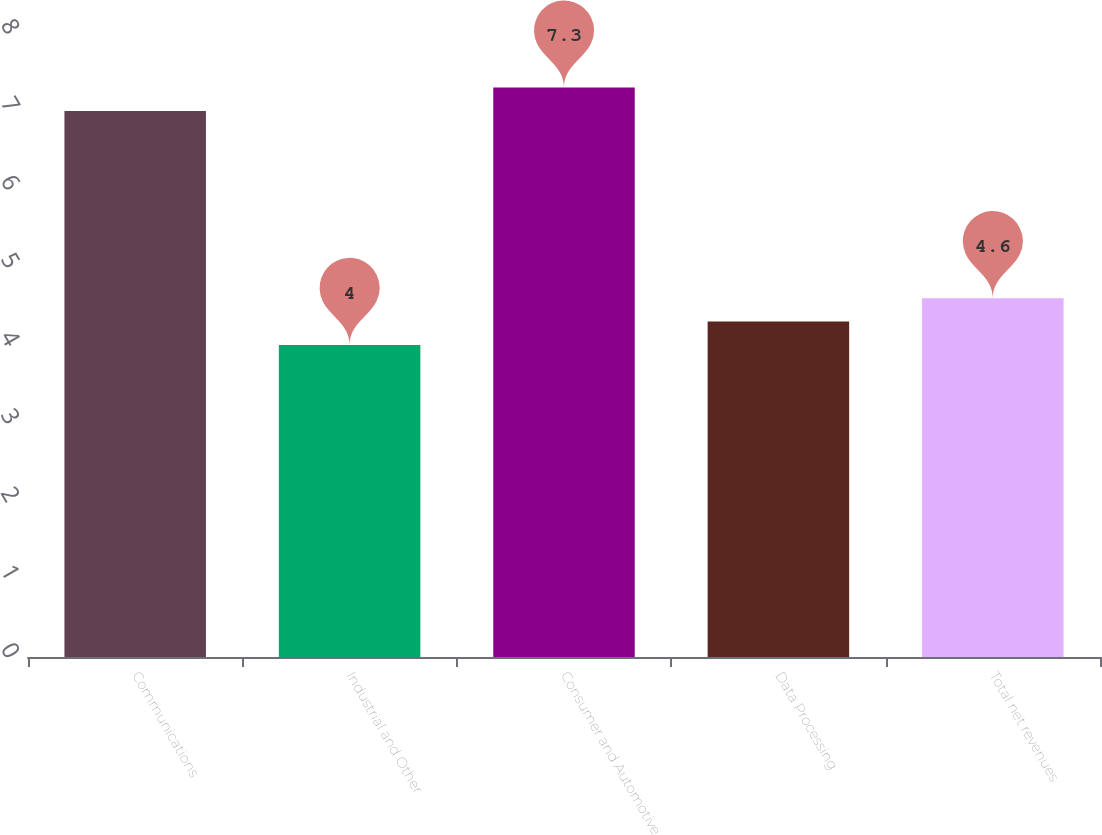<chart> <loc_0><loc_0><loc_500><loc_500><bar_chart><fcel>Communications<fcel>Industrial and Other<fcel>Consumer and Automotive<fcel>Data Processing<fcel>Total net revenues<nl><fcel>7<fcel>4<fcel>7.3<fcel>4.3<fcel>4.6<nl></chart> 